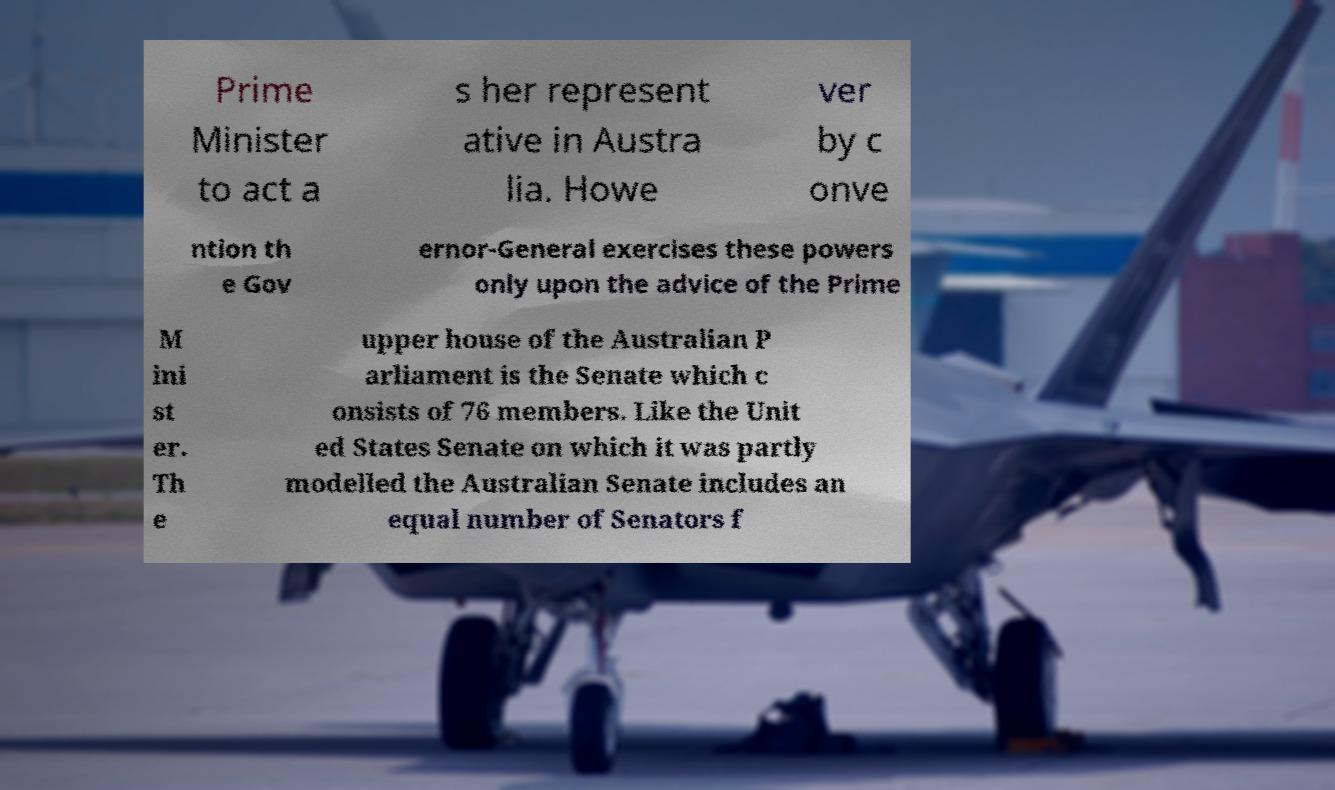There's text embedded in this image that I need extracted. Can you transcribe it verbatim? Prime Minister to act a s her represent ative in Austra lia. Howe ver by c onve ntion th e Gov ernor-General exercises these powers only upon the advice of the Prime M ini st er. Th e upper house of the Australian P arliament is the Senate which c onsists of 76 members. Like the Unit ed States Senate on which it was partly modelled the Australian Senate includes an equal number of Senators f 